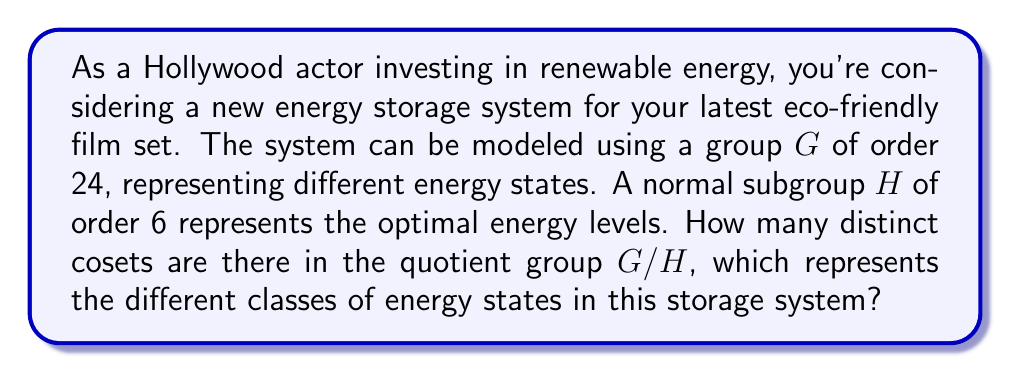Help me with this question. To solve this problem, we'll use the following steps:

1) Recall the Lagrange's Theorem, which states that for a finite group $G$ and a subgroup $H$ of $G$, the order of $H$ divides the order of $G$. Mathematically:

   $$ |G| = |H| \cdot [G:H] $$

   where $[G:H]$ is the index of $H$ in $G$, which is equal to the number of distinct cosets of $H$ in $G$.

2) We are given that:
   $$ |G| = 24 $$
   $$ |H| = 6 $$

3) Substituting these values into Lagrange's Theorem:

   $$ 24 = 6 \cdot [G:H] $$

4) Solving for $[G:H]$:

   $$ [G:H] = \frac{24}{6} = 4 $$

5) The number of distinct cosets in $G/H$ is equal to the index $[G:H]$.

Therefore, there are 4 distinct cosets in the quotient group $G/H$.

This means that the energy storage system can be classified into 4 distinct classes of energy states, which could represent different levels of charge or efficiency in the system.
Answer: 4 distinct cosets 